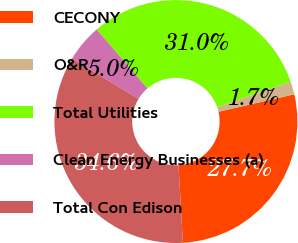Convert chart. <chart><loc_0><loc_0><loc_500><loc_500><pie_chart><fcel>CECONY<fcel>O&R<fcel>Total Utilities<fcel>Clean Energy Businesses (a)<fcel>Total Con Edison<nl><fcel>27.68%<fcel>1.73%<fcel>30.97%<fcel>5.02%<fcel>34.6%<nl></chart> 